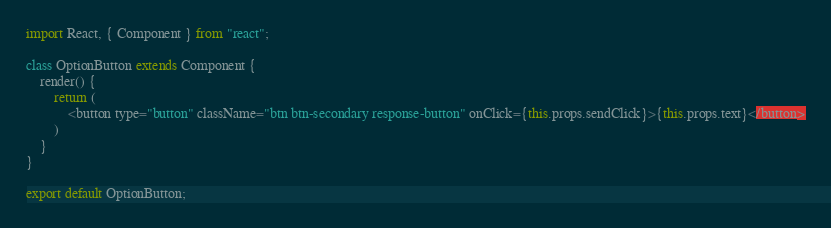Convert code to text. <code><loc_0><loc_0><loc_500><loc_500><_JavaScript_>import React, { Component } from "react";

class OptionButton extends Component {
    render() {
        return (
            <button type="button" className="btn btn-secondary response-button" onClick={this.props.sendClick}>{this.props.text}</button>
        )
    }
}

export default OptionButton;</code> 